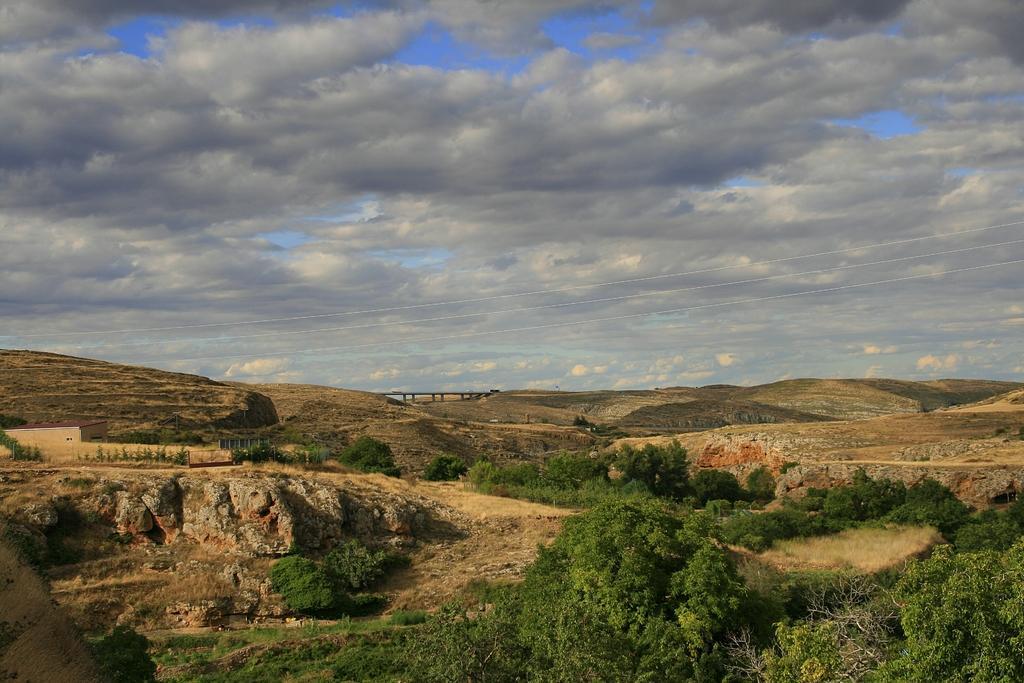Please provide a concise description of this image. In the picture we can see some trees and beside it, we can see part of the rock hill and muddy surface on it and behind it also we can see some hills and a bridge on it and in the background we can see the sky with clouds. 